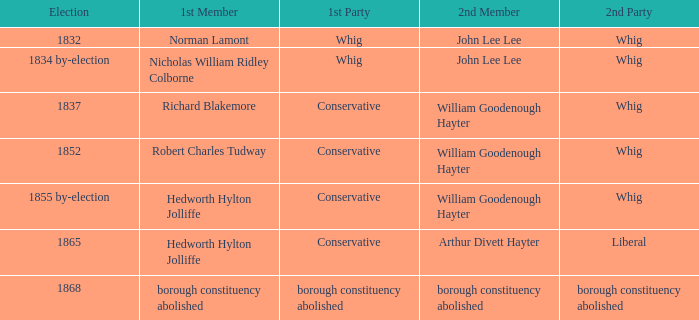Who's the conservative 1st member of the election of 1852? Robert Charles Tudway. 